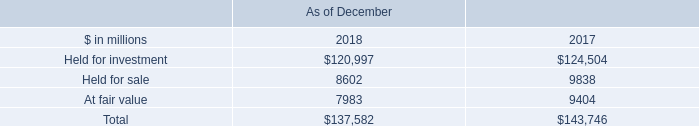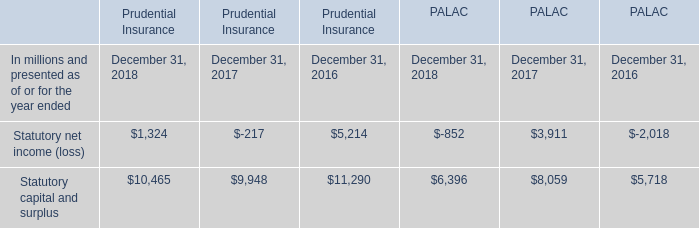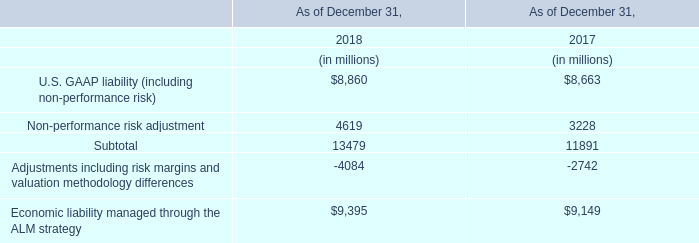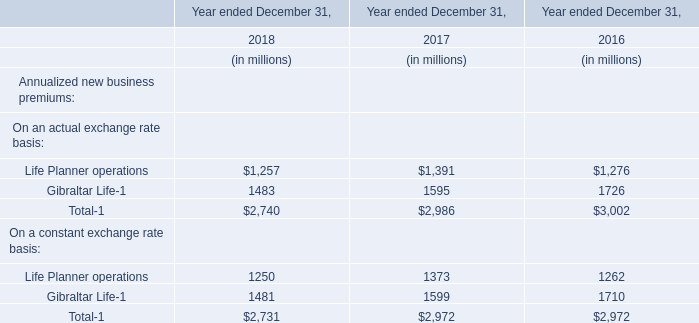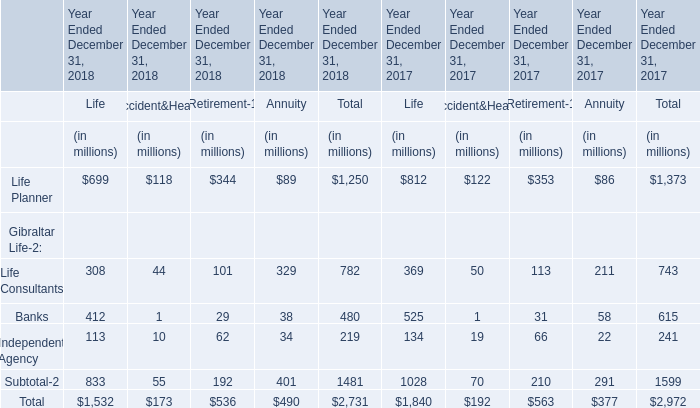What was the average value of the Banks in the years where Life Planner is positive? (in million) 
Computations: ((480 + 615) / 2)
Answer: 547.5. 